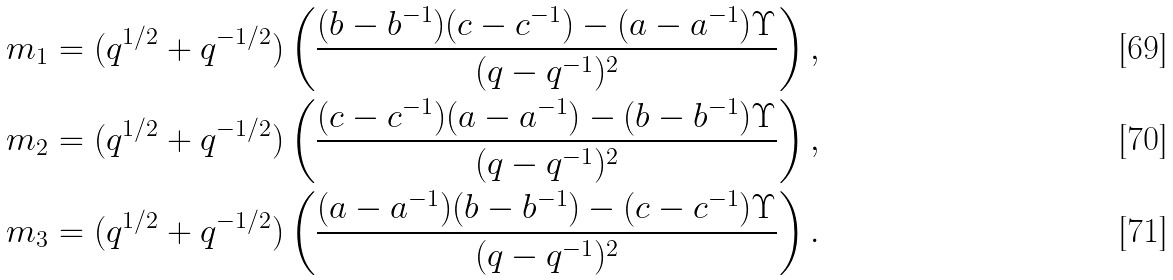<formula> <loc_0><loc_0><loc_500><loc_500>m _ { 1 } & = ( q ^ { 1 / 2 } + q ^ { - 1 / 2 } ) \left ( \frac { ( b - b ^ { - 1 } ) ( c - c ^ { - 1 } ) - ( a - a ^ { - 1 } ) \Upsilon } { ( q - q ^ { - 1 } ) ^ { 2 } } \right ) , \\ m _ { 2 } & = ( q ^ { 1 / 2 } + q ^ { - 1 / 2 } ) \left ( \frac { ( c - c ^ { - 1 } ) ( a - a ^ { - 1 } ) - ( b - b ^ { - 1 } ) \Upsilon } { ( q - q ^ { - 1 } ) ^ { 2 } } \right ) , \\ m _ { 3 } & = ( q ^ { 1 / 2 } + q ^ { - 1 / 2 } ) \left ( \frac { ( a - a ^ { - 1 } ) ( b - b ^ { - 1 } ) - ( c - c ^ { - 1 } ) \Upsilon } { ( q - q ^ { - 1 } ) ^ { 2 } } \right ) .</formula> 